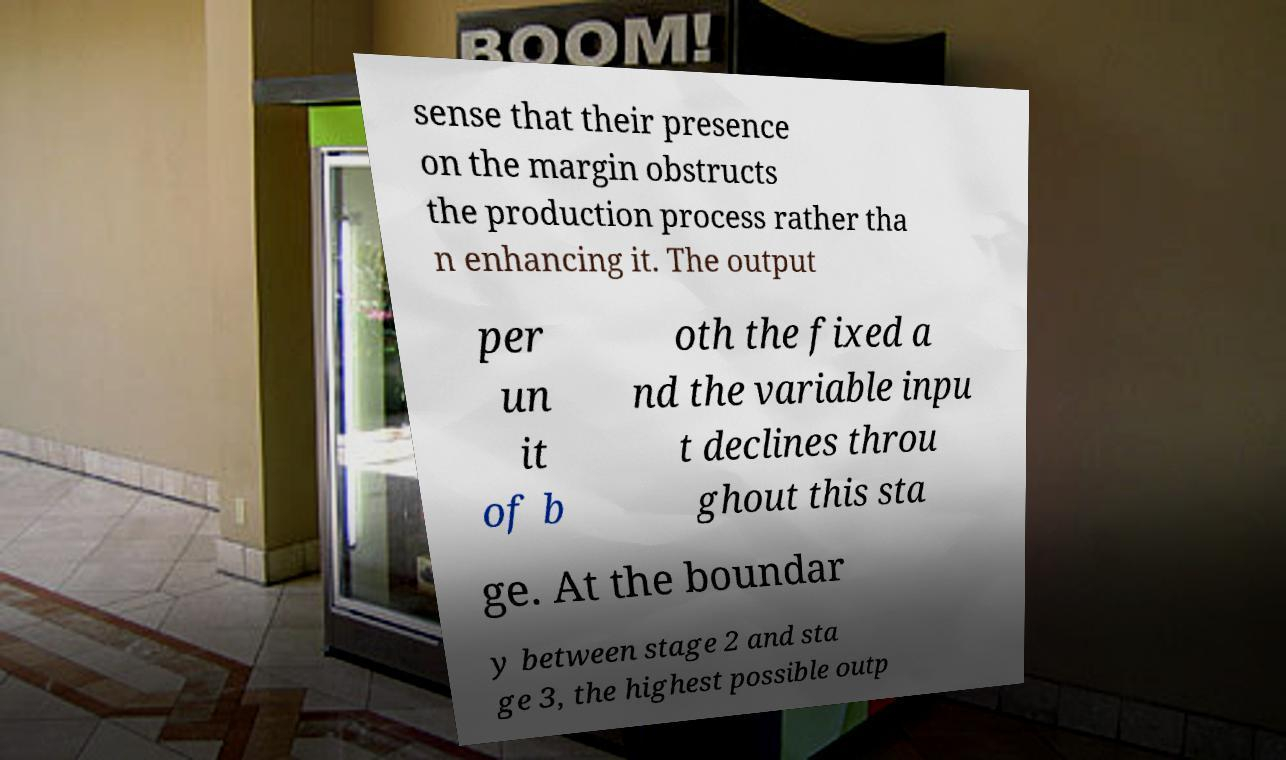I need the written content from this picture converted into text. Can you do that? sense that their presence on the margin obstructs the production process rather tha n enhancing it. The output per un it of b oth the fixed a nd the variable inpu t declines throu ghout this sta ge. At the boundar y between stage 2 and sta ge 3, the highest possible outp 